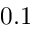Convert formula to latex. <formula><loc_0><loc_0><loc_500><loc_500>0 . 1</formula> 